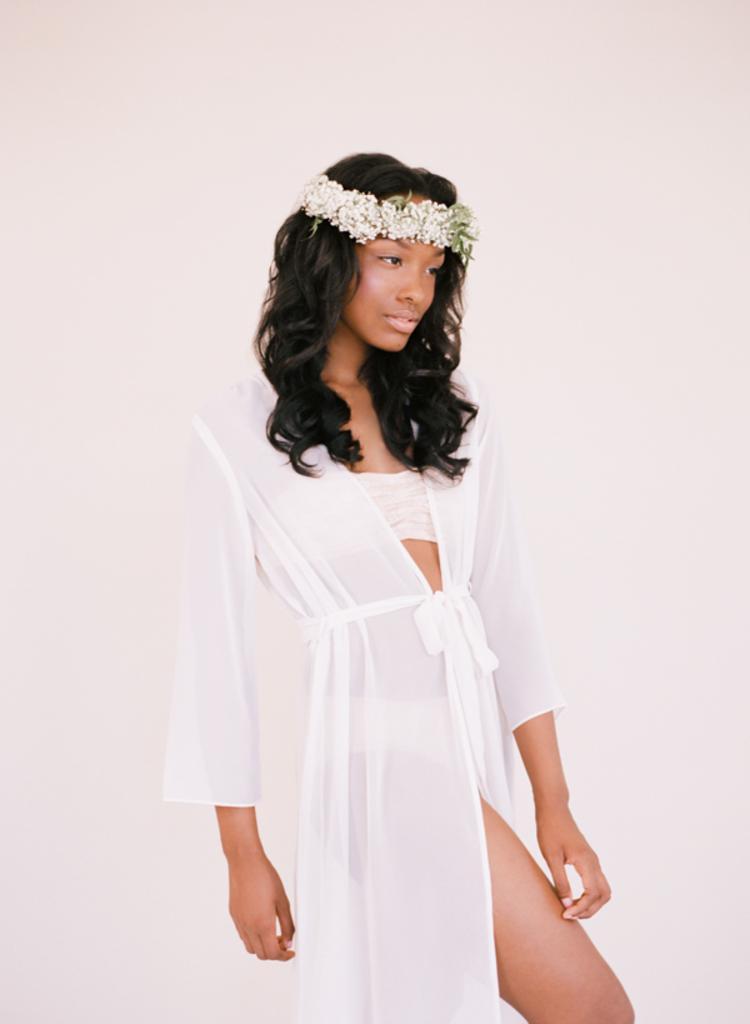How would you summarize this image in a sentence or two? As we can see in the image there is a white color wall and a woman wearing white color dress. 